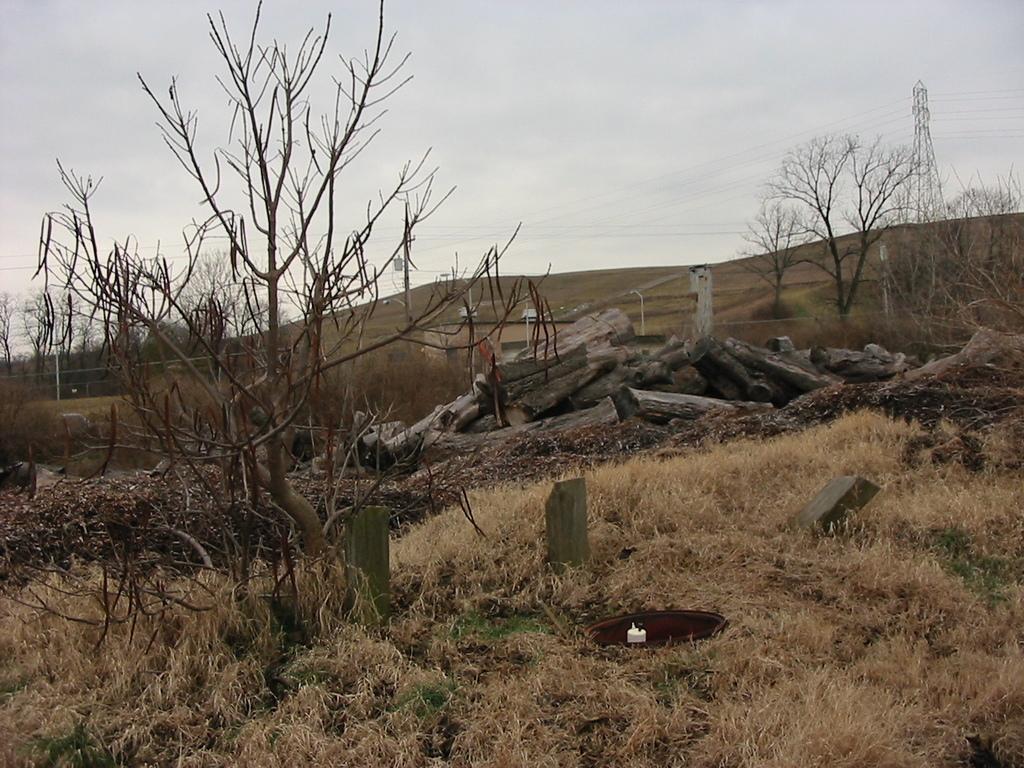In one or two sentences, can you explain what this image depicts? In this picture I can see the grass, few stones, log of woods and number of trees in front. In the background I can see the wires, a tower and the sky. 